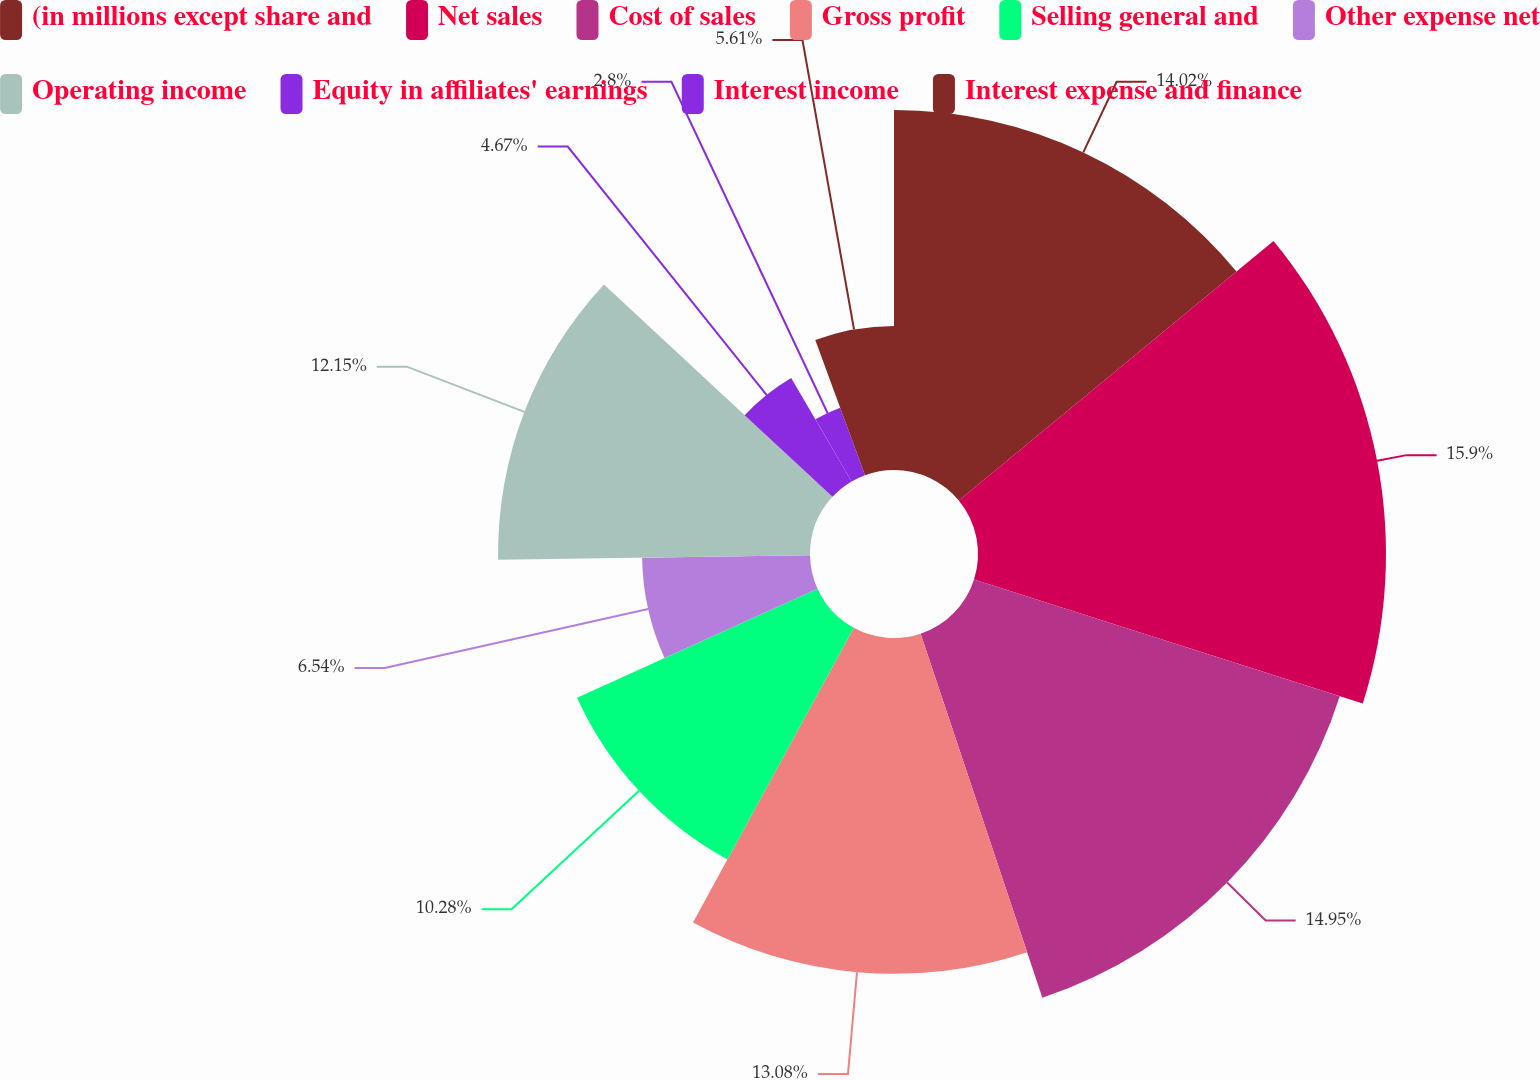Convert chart to OTSL. <chart><loc_0><loc_0><loc_500><loc_500><pie_chart><fcel>(in millions except share and<fcel>Net sales<fcel>Cost of sales<fcel>Gross profit<fcel>Selling general and<fcel>Other expense net<fcel>Operating income<fcel>Equity in affiliates' earnings<fcel>Interest income<fcel>Interest expense and finance<nl><fcel>14.02%<fcel>15.89%<fcel>14.95%<fcel>13.08%<fcel>10.28%<fcel>6.54%<fcel>12.15%<fcel>4.67%<fcel>2.8%<fcel>5.61%<nl></chart> 